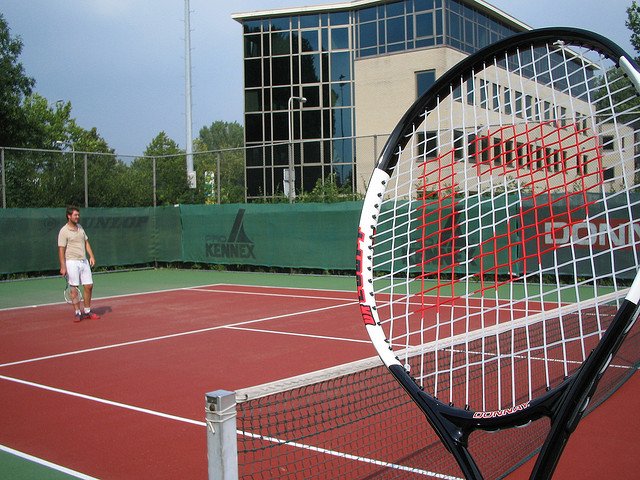What kind of physical skills or attributes are beneficial for playing this sport? This sport requires a combination of physical skills and attributes, including agility, endurance, speed, flexibility, and coordination. Players must be able to execute precise and powerful strokes, have quick reflexes for volleys and returns, and possess strategic thinking to outmaneuver opponents. 